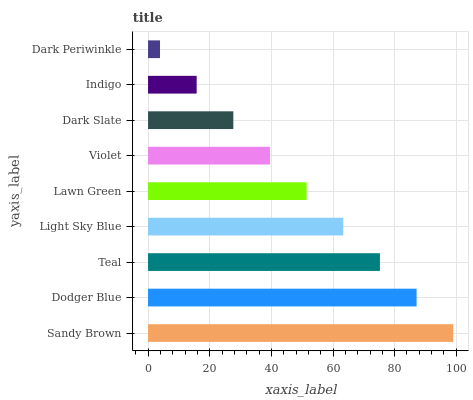Is Dark Periwinkle the minimum?
Answer yes or no. Yes. Is Sandy Brown the maximum?
Answer yes or no. Yes. Is Dodger Blue the minimum?
Answer yes or no. No. Is Dodger Blue the maximum?
Answer yes or no. No. Is Sandy Brown greater than Dodger Blue?
Answer yes or no. Yes. Is Dodger Blue less than Sandy Brown?
Answer yes or no. Yes. Is Dodger Blue greater than Sandy Brown?
Answer yes or no. No. Is Sandy Brown less than Dodger Blue?
Answer yes or no. No. Is Lawn Green the high median?
Answer yes or no. Yes. Is Lawn Green the low median?
Answer yes or no. Yes. Is Dark Periwinkle the high median?
Answer yes or no. No. Is Dark Slate the low median?
Answer yes or no. No. 